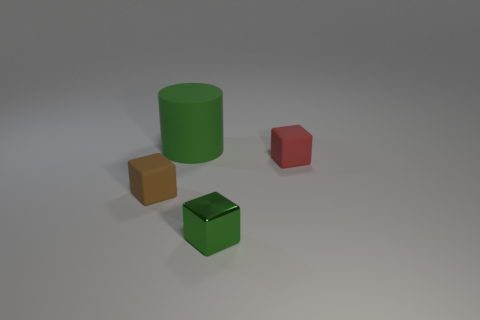Add 1 matte balls. How many objects exist? 5 Subtract all cylinders. How many objects are left? 3 Subtract all small shiny blocks. Subtract all big cyan objects. How many objects are left? 3 Add 1 shiny things. How many shiny things are left? 2 Add 2 small green metallic objects. How many small green metallic objects exist? 3 Subtract 0 blue cylinders. How many objects are left? 4 